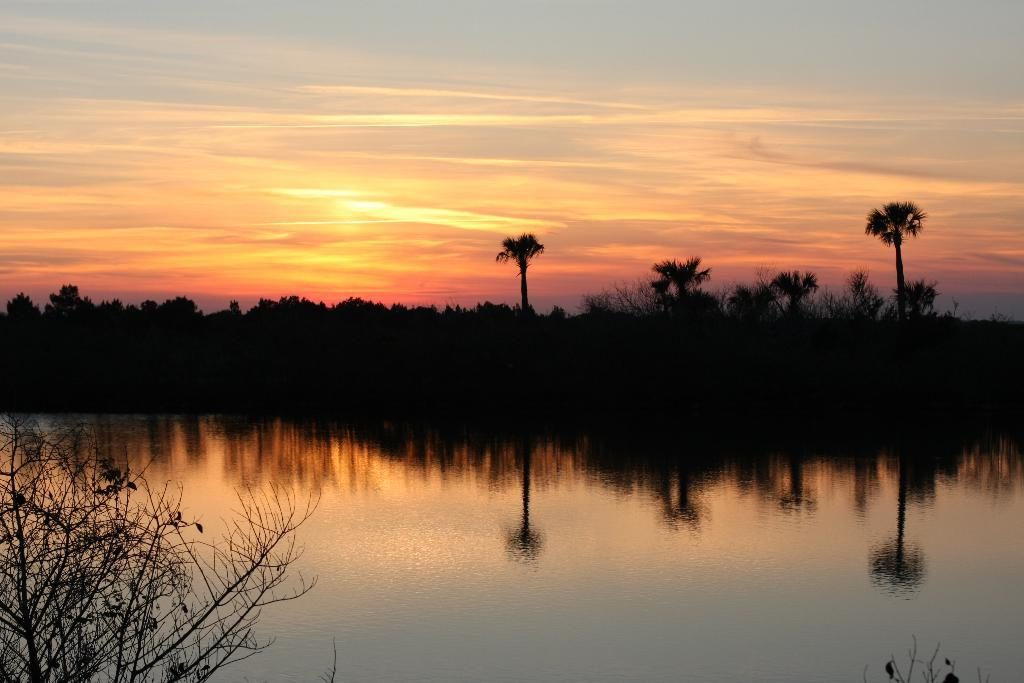What is the primary element visible in the image? There is water in the image. What type of natural vegetation can be seen in the image? There are trees in the image. What part of the trees is visible in the image? Tree branches are visible in the image. How would you describe the color of the sky in the image? The sky has a pale orange color. Where is the crayon located in the image? There is no crayon present in the image. 